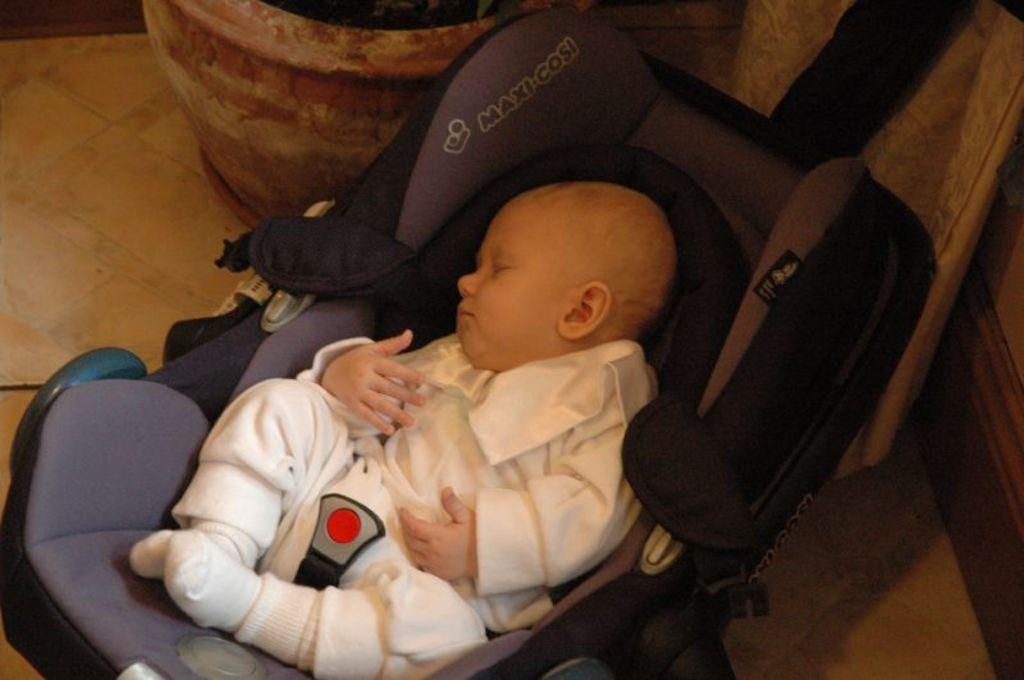What is the main subject of the image? There is a baby sleeping in a trolley. Where is the trolley located in the image? The trolley is on the floor. What can be seen in the upper left corner of the image? There is a potted plant on the left top of the image. What is visible on the right side of the image? There appears to be a door on the right side of the image. What type of ornament is hanging from the door in the image? There is no ornament hanging from the door in the image; the door is simply visible on the right side. 